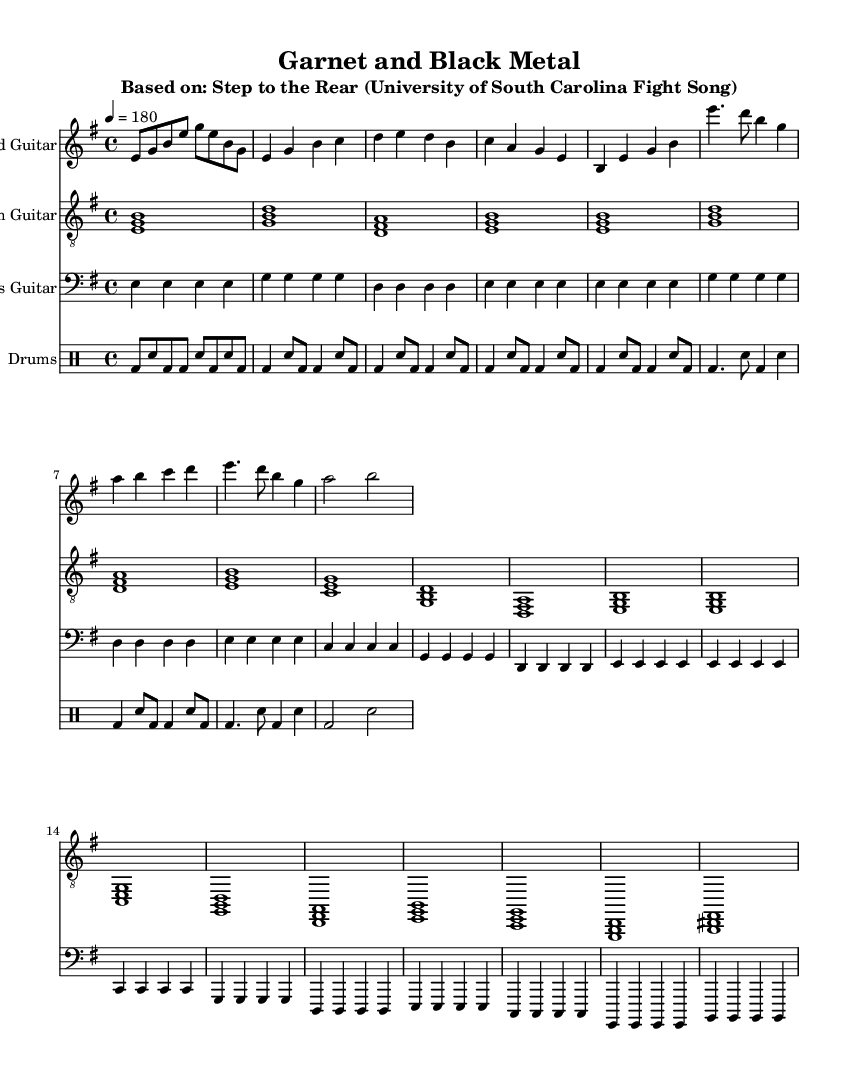What is the key signature of this music? The key signature is determined by looking at the beginning of the staff where the key signatures are indicated. In this case, the sharp symbol is not present, and the notes primarily include E, G, B, D, and A, which are consistent with E minor.
Answer: E minor What is the time signature of this music? The time signature is found at the beginning of the score, where the music staff shows 4/4. This indicates that there are four beats per measure, and each quarter note gets one beat.
Answer: 4/4 What is the tempo marking for this piece? The tempo marking is specified in the score, which indicates how fast the music should be played. In this score, it shows "4 = 180," meaning there are 180 beats per minute.
Answer: 180 How many measures are there in the chorus section? To determine the number of measures in the chorus section, I can count the measures indicated under the chorus section in the staff. There are 4 measures in the chorus.
Answer: 4 What instruments are featured in the arrangement? The score lists the different parts at the beginning, which includes "Lead Guitar," "Rhythm Guitar," "Bass Guitar," and "Drums." These tell me which instruments are arranged for this piece.
Answer: Lead Guitar, Rhythm Guitar, Bass Guitar, Drums What type of chord progression is primarily used in the verse? I can analyze the harmonies played during the verse. The chords are based on E minor, and the progression mostly follows a standard I-IV-V pattern that is typical for metal arrangements.
Answer: I-IV-V progression What is the overall style of the music based on the arrangement? The arrangement employs heavy guitar riffs with a fast tempo, layered harmonies, and an aggressive drumming pattern, which are characteristic of the metal genre.
Answer: Metal 